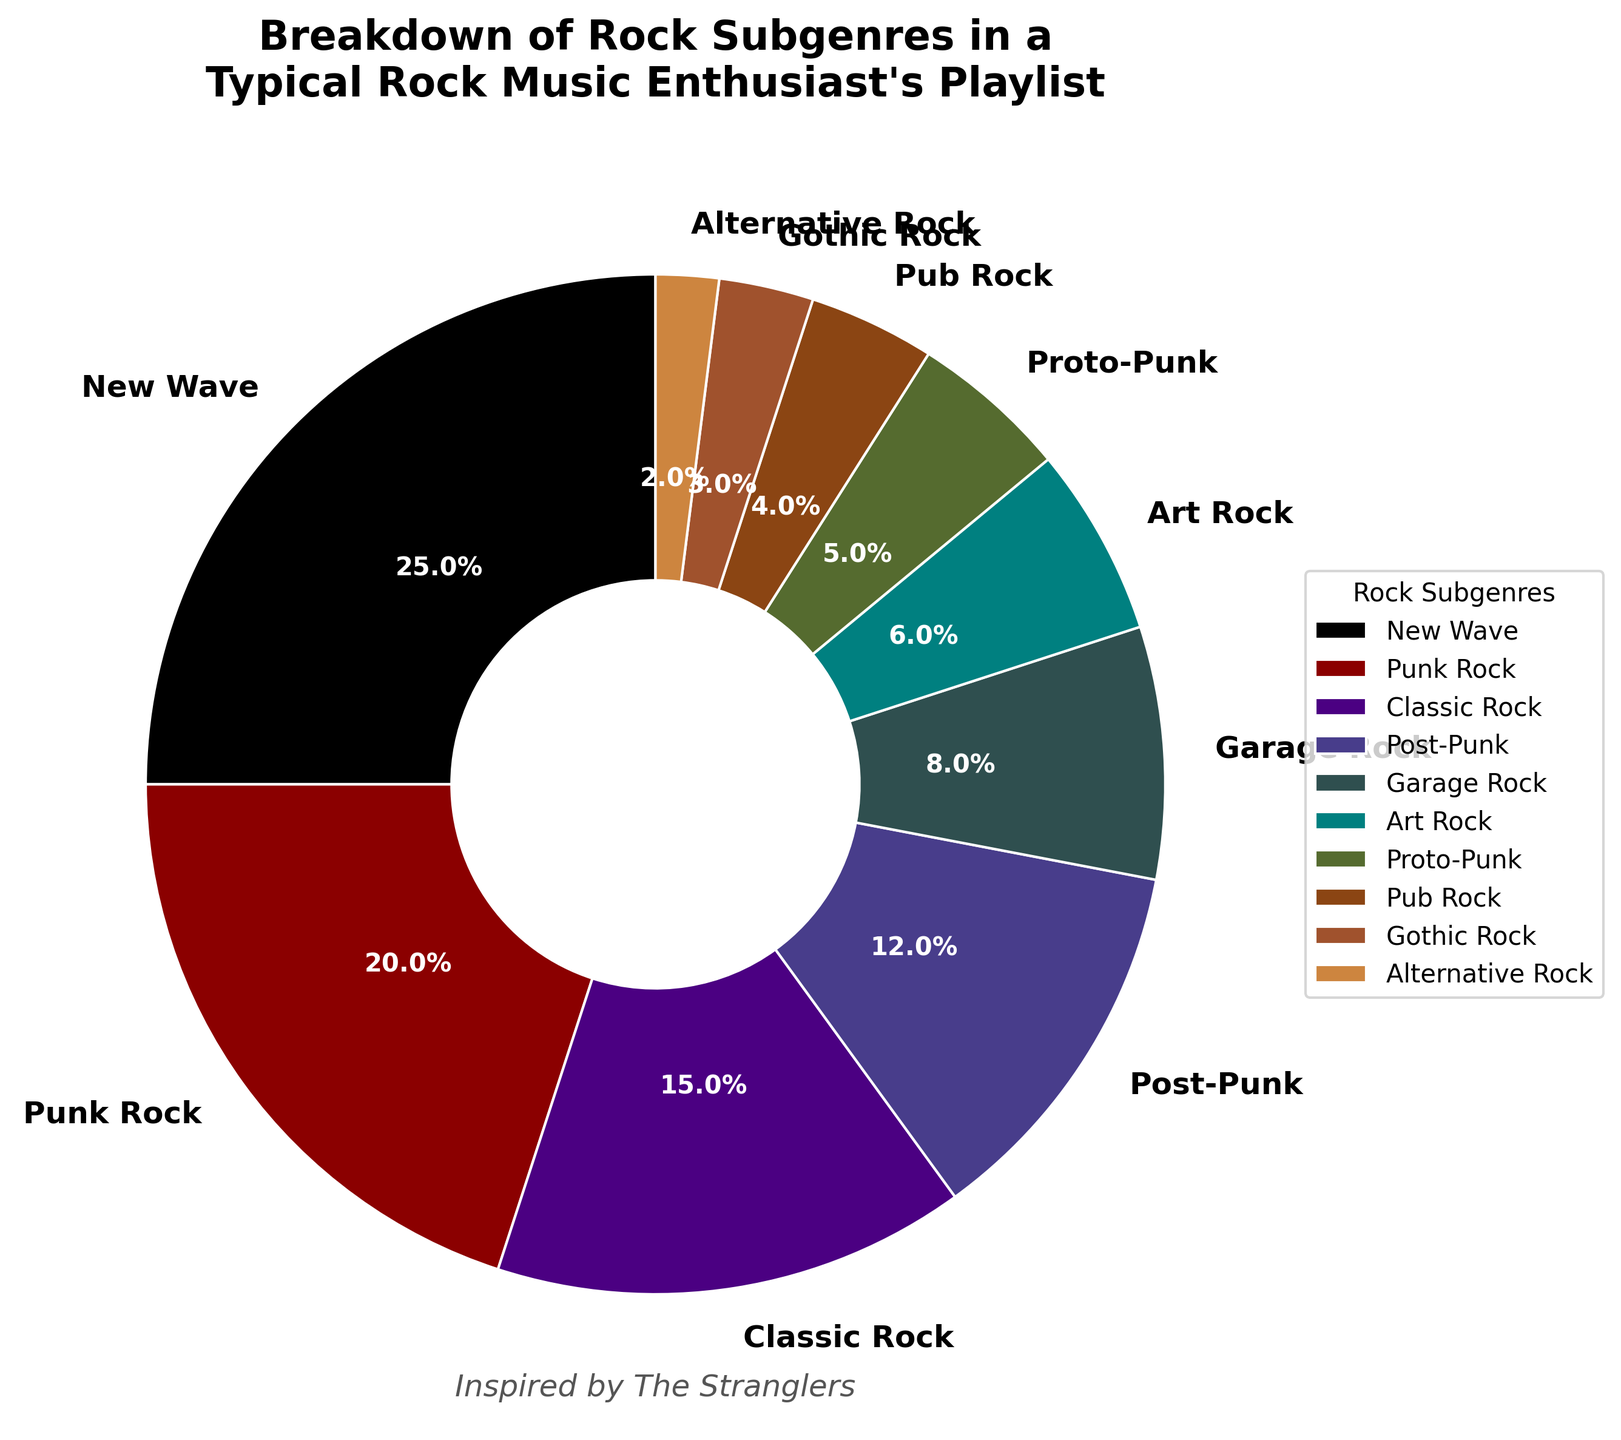Which subgenre has the highest percentage? Refer to the pie chart and identify the subgenre with the largest wedge. The largest wedge is marked with "New Wave" at 25%.
Answer: New Wave Which three subgenres together make up the largest portion of the playlist? The top three subgenres by percentage are "New Wave" (25%), "Punk Rock" (20%), and "Classic Rock" (15%). Adding these, we get 25% + 20% + 15% = 60%.
Answer: New Wave, Punk Rock, Classic Rock What is the difference in percentage between the highest and the lowest subgenres? From the pie chart, the highest is "New Wave" at 25% and the lowest is "Alternative Rock" at 2%. The difference is 25% - 2% = 23%.
Answer: 23% How many subgenres have a percentage greater than 10%? Scan the pie chart for subgenres with percentages above 10%. These are "New Wave" (25%), "Punk Rock" (20%), "Classic Rock" (15%), and "Post-Punk" (12%). Count them to get 4.
Answer: 4 Does "Garage Rock" make up a larger portion of the playlist than "Proto-Punk"? Compare the percentages of "Garage Rock" (8%) and "Proto-Punk" (5%) from the pie chart. "Garage Rock" has a higher percentage.
Answer: Yes What is the combined percentage of the subgenres with the smallest representation? Identify the subgenres with the smallest percentages: "Pub Rock" (4%), "Gothic Rock" (3%), and "Alternative Rock" (2%). Add these percentages: 4% + 3% + 2% = 9%.
Answer: 9% What subgenre represents a quarter of the playlist? Identify the subgenre with a percentage of around 25% from the pie chart. "New Wave" makes up exactly 25% of the playlist.
Answer: New Wave Which subgenre is represented by a dark red color in the chart? Refer to the color coding of the wedges in the pie chart. The dark red wedge represents "Punk Rock" with 20%.
Answer: Punk Rock 